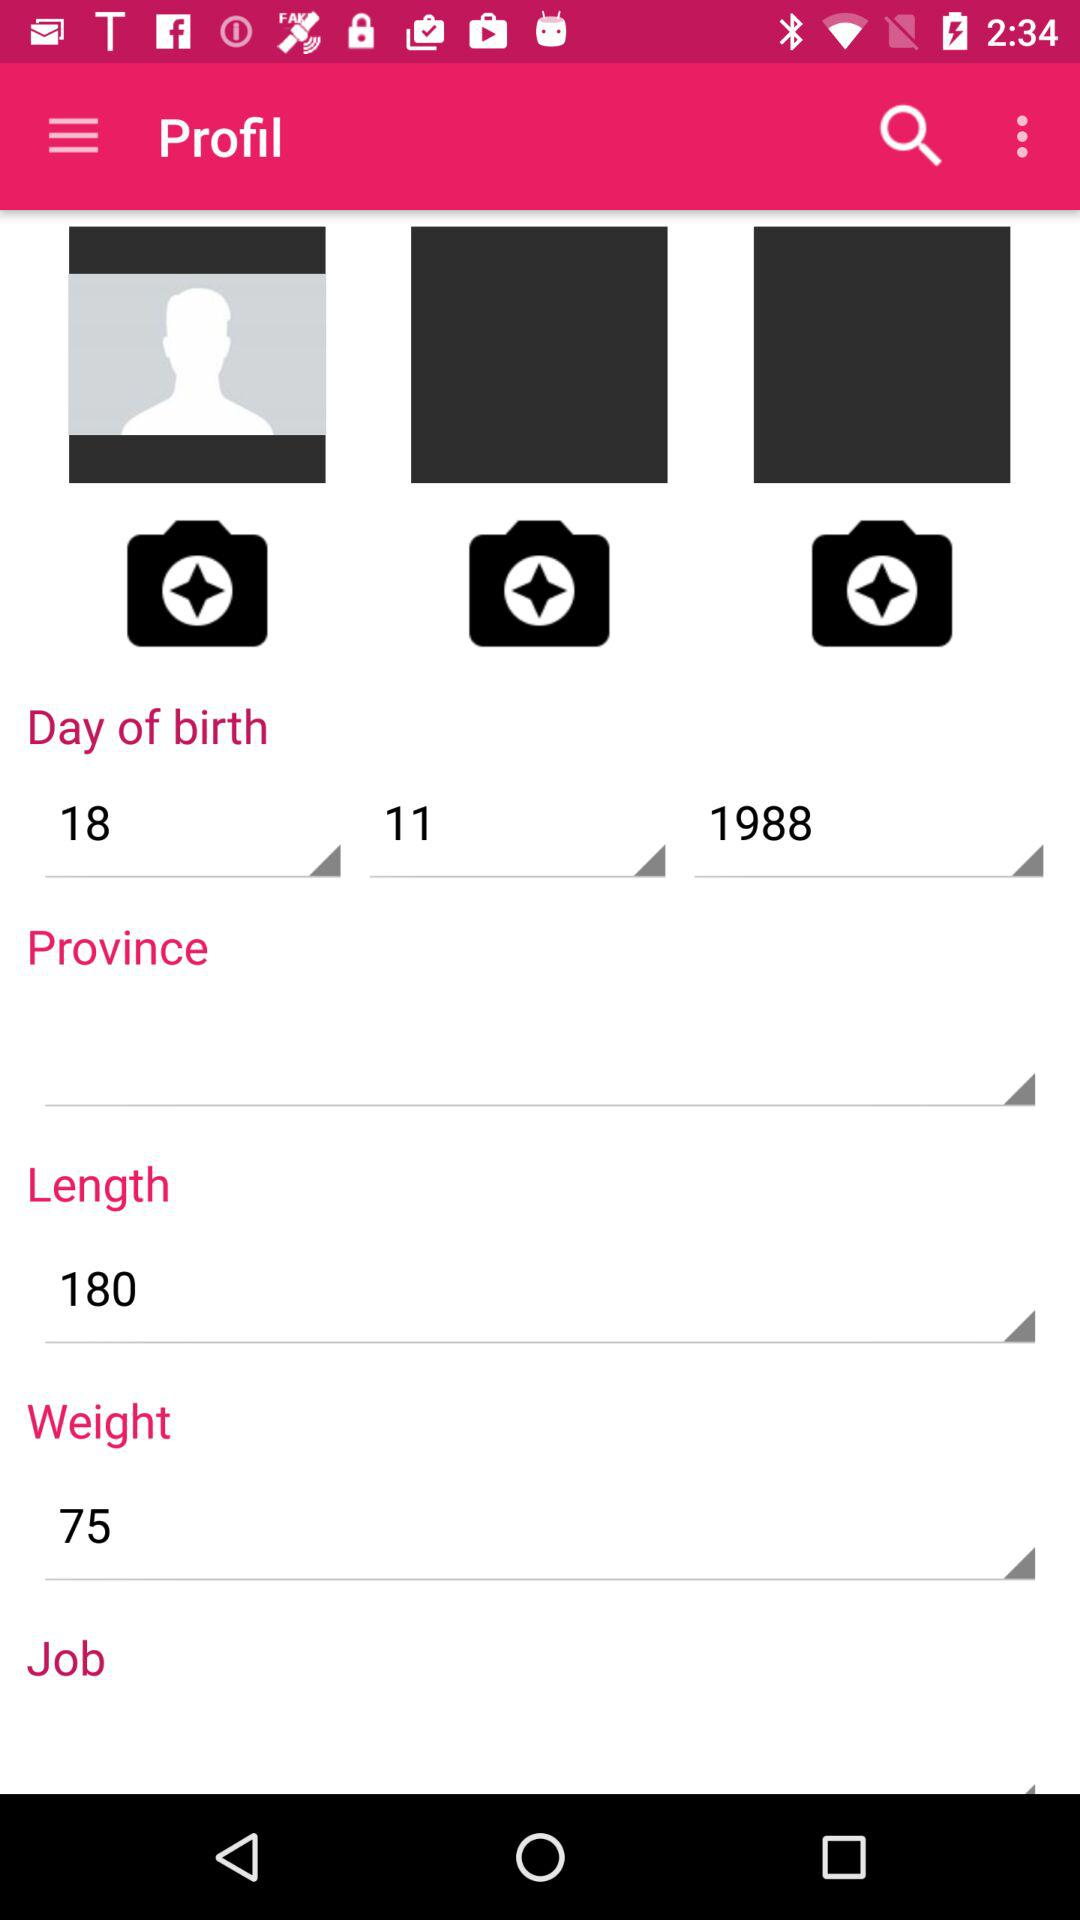What is the weight of the user in the profile? The weight of the user in the profile is 75. 